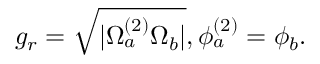Convert formula to latex. <formula><loc_0><loc_0><loc_500><loc_500>g _ { r } = \sqrt { | \Omega _ { a } ^ { ( 2 ) } \Omega _ { b } | } , \phi _ { a } ^ { ( 2 ) } = \phi _ { b } .</formula> 